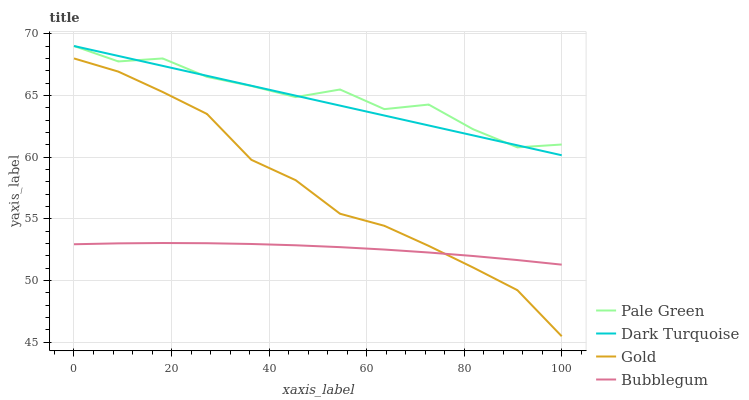Does Bubblegum have the minimum area under the curve?
Answer yes or no. Yes. Does Pale Green have the maximum area under the curve?
Answer yes or no. Yes. Does Pale Green have the minimum area under the curve?
Answer yes or no. No. Does Bubblegum have the maximum area under the curve?
Answer yes or no. No. Is Dark Turquoise the smoothest?
Answer yes or no. Yes. Is Pale Green the roughest?
Answer yes or no. Yes. Is Bubblegum the smoothest?
Answer yes or no. No. Is Bubblegum the roughest?
Answer yes or no. No. Does Gold have the lowest value?
Answer yes or no. Yes. Does Bubblegum have the lowest value?
Answer yes or no. No. Does Pale Green have the highest value?
Answer yes or no. Yes. Does Bubblegum have the highest value?
Answer yes or no. No. Is Gold less than Dark Turquoise?
Answer yes or no. Yes. Is Pale Green greater than Bubblegum?
Answer yes or no. Yes. Does Dark Turquoise intersect Pale Green?
Answer yes or no. Yes. Is Dark Turquoise less than Pale Green?
Answer yes or no. No. Is Dark Turquoise greater than Pale Green?
Answer yes or no. No. Does Gold intersect Dark Turquoise?
Answer yes or no. No. 